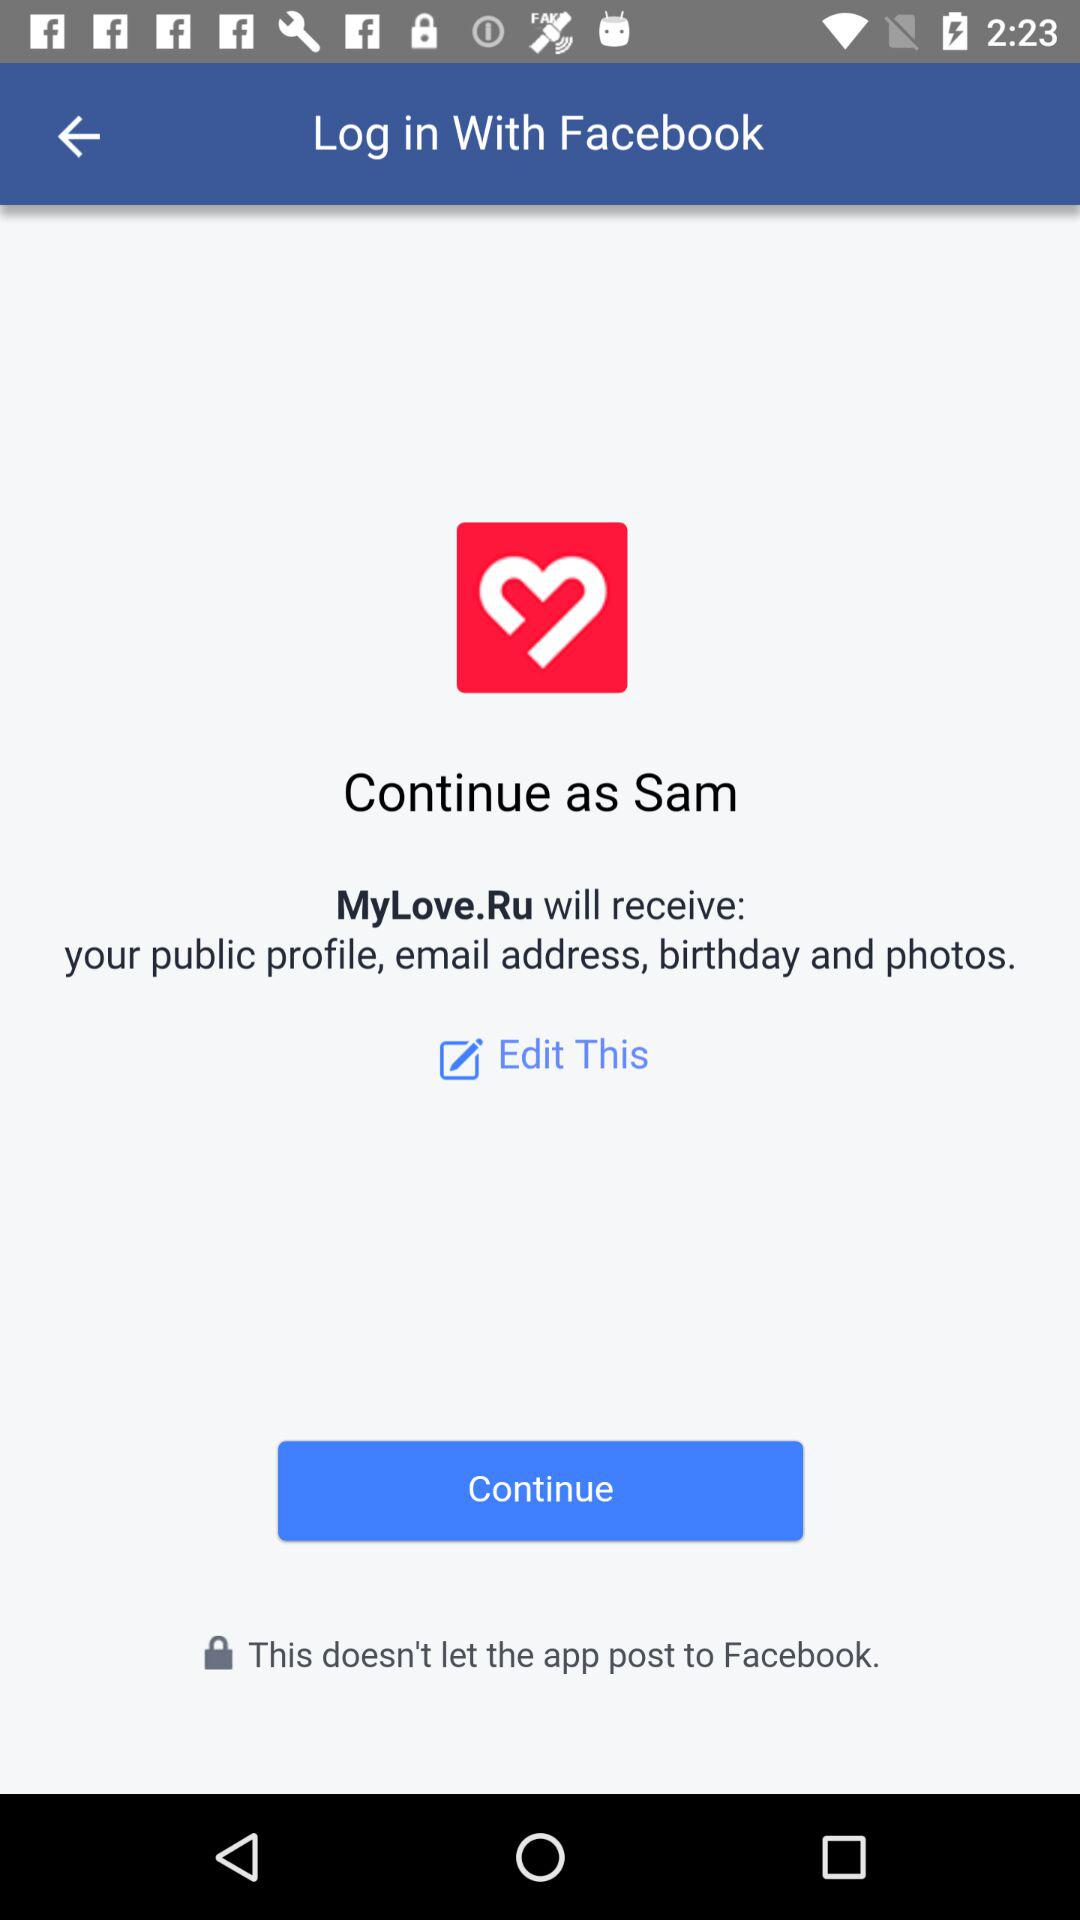What is the user name? The user name is Sam. 